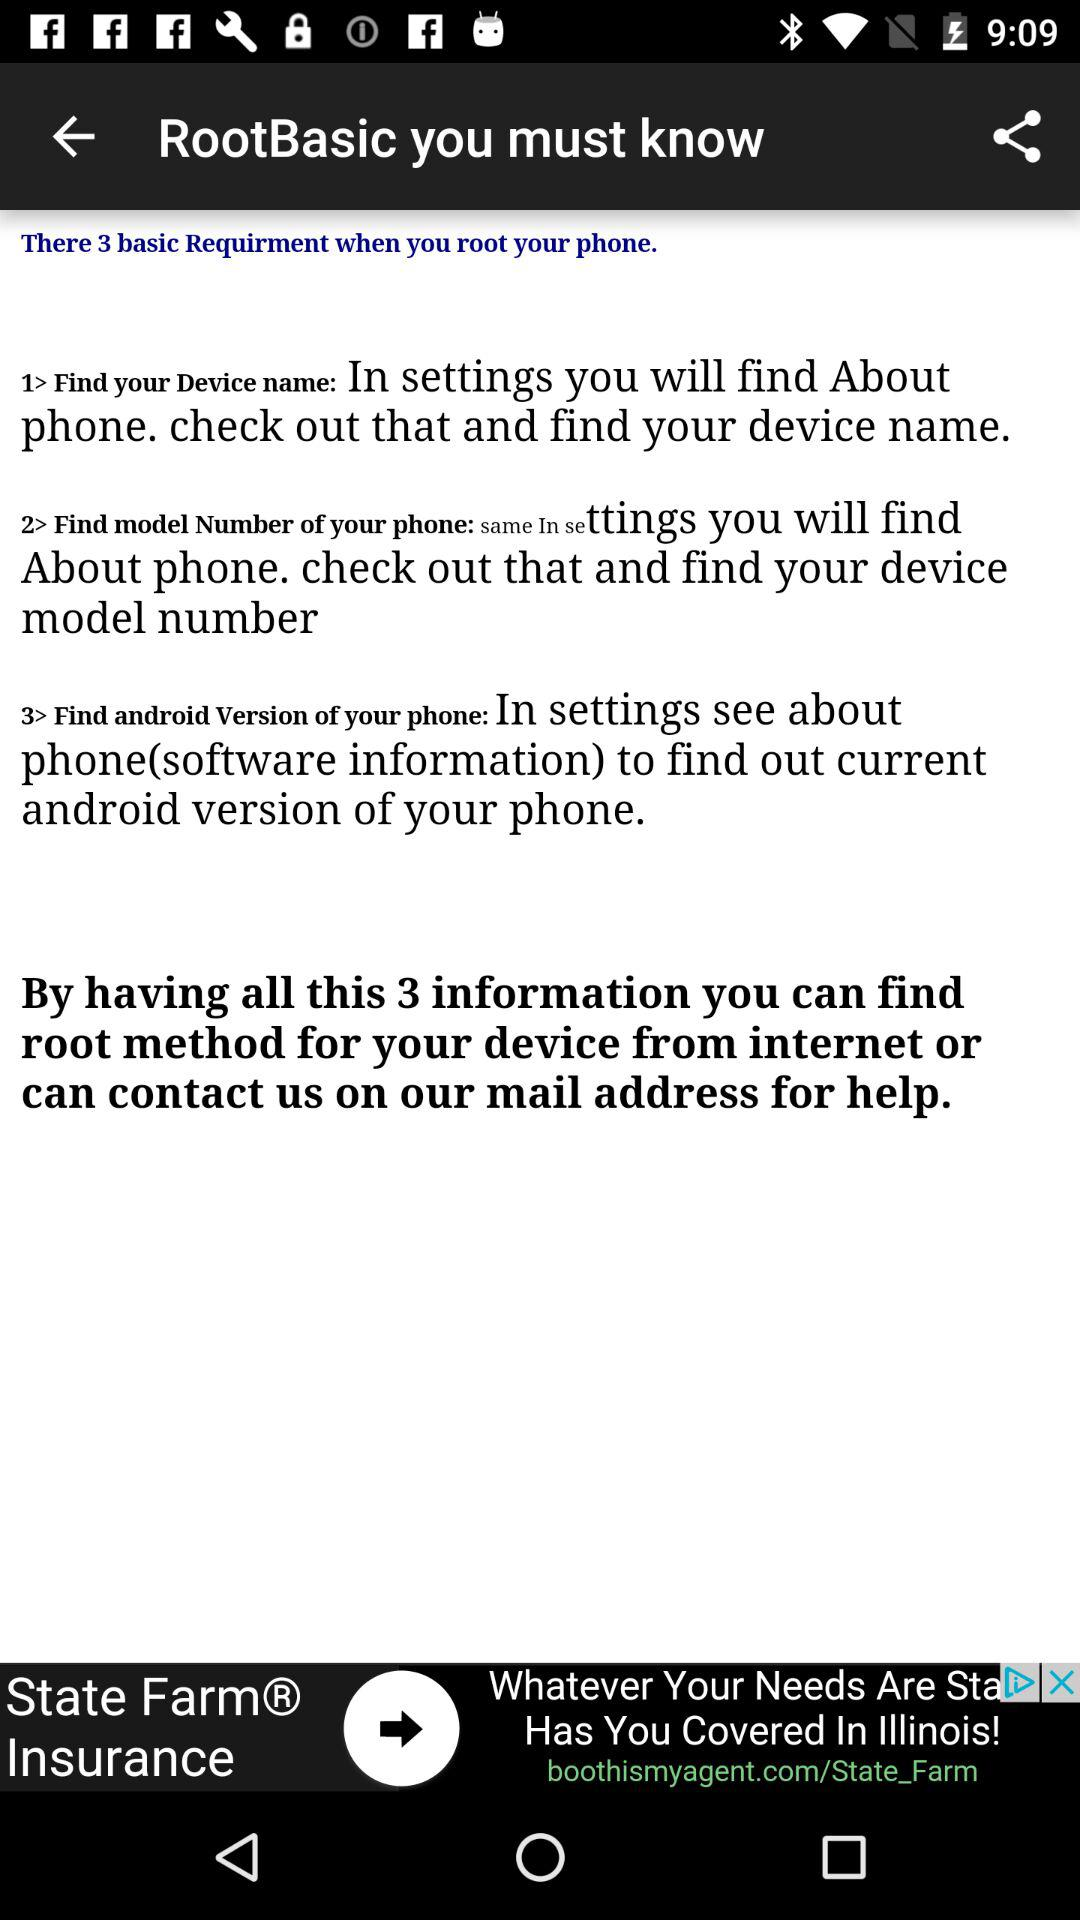How many steps are required to root a phone?
Answer the question using a single word or phrase. 3 